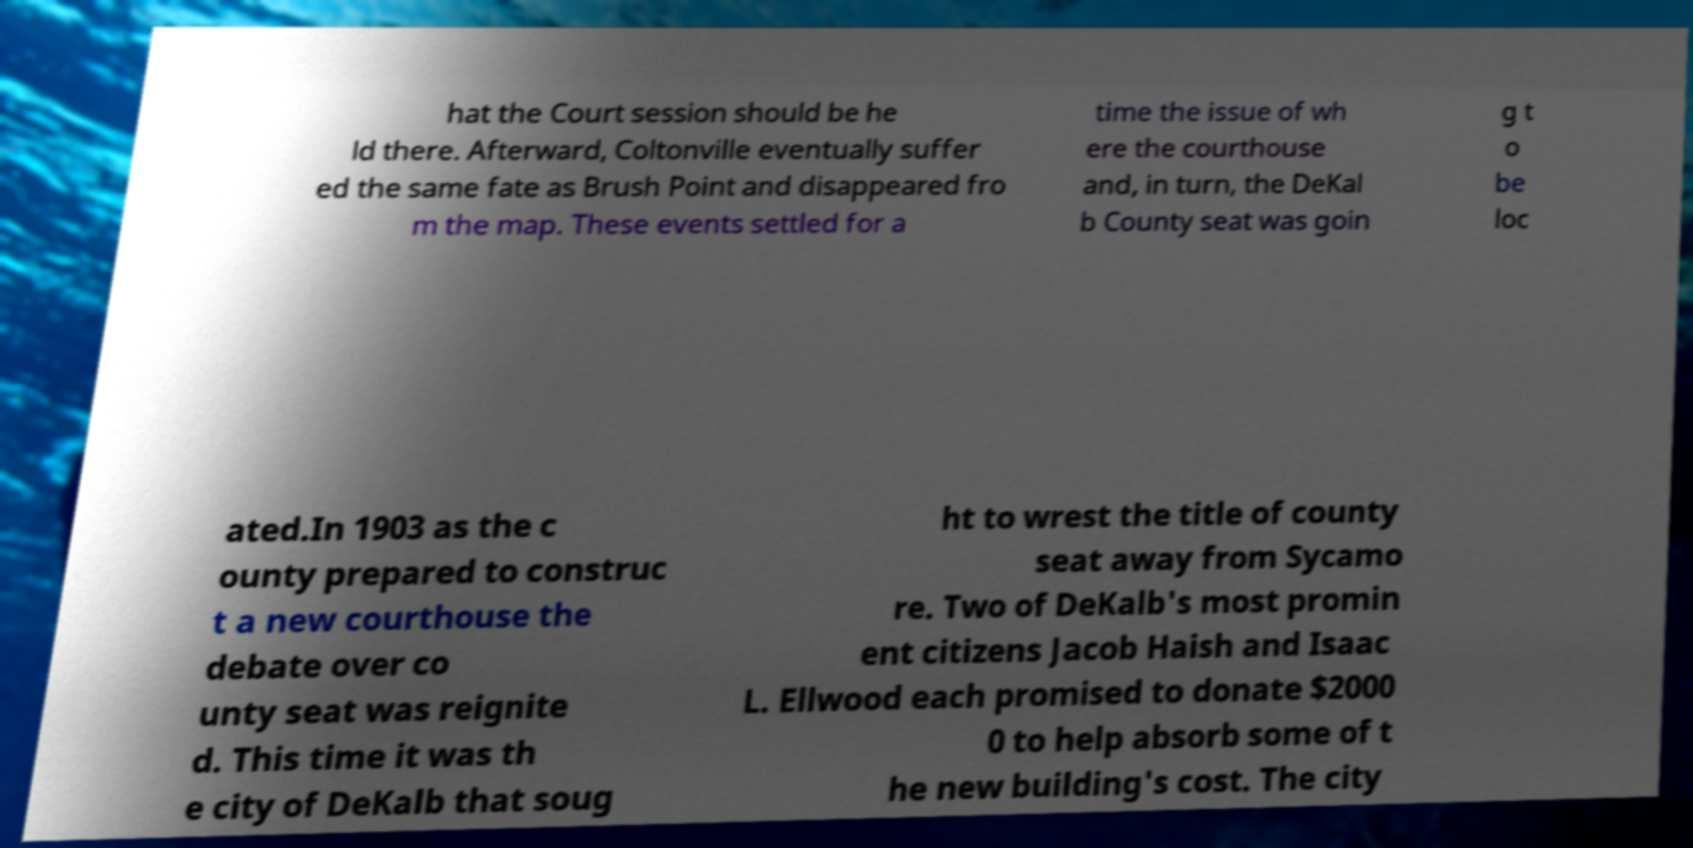There's text embedded in this image that I need extracted. Can you transcribe it verbatim? hat the Court session should be he ld there. Afterward, Coltonville eventually suffer ed the same fate as Brush Point and disappeared fro m the map. These events settled for a time the issue of wh ere the courthouse and, in turn, the DeKal b County seat was goin g t o be loc ated.In 1903 as the c ounty prepared to construc t a new courthouse the debate over co unty seat was reignite d. This time it was th e city of DeKalb that soug ht to wrest the title of county seat away from Sycamo re. Two of DeKalb's most promin ent citizens Jacob Haish and Isaac L. Ellwood each promised to donate $2000 0 to help absorb some of t he new building's cost. The city 